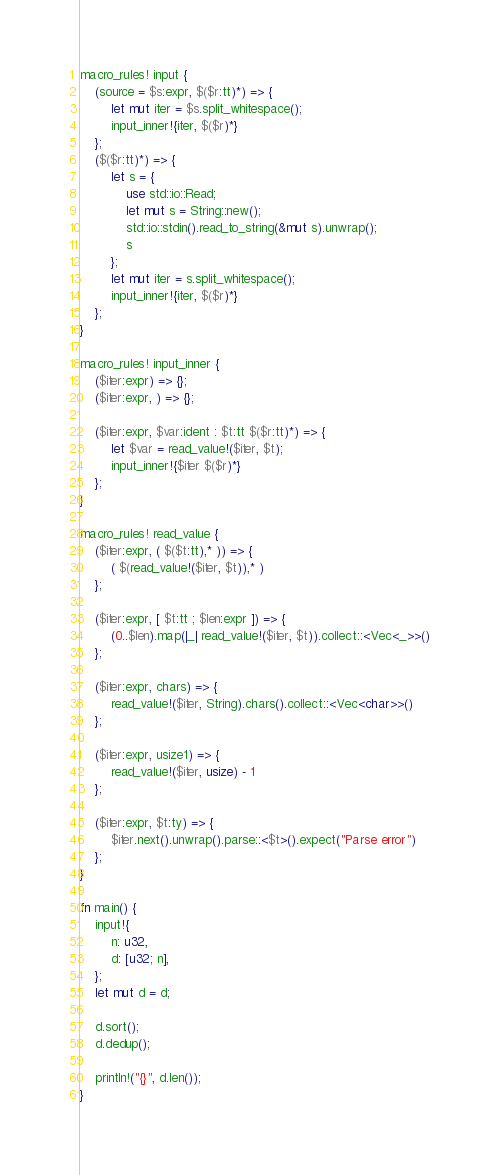<code> <loc_0><loc_0><loc_500><loc_500><_Rust_>macro_rules! input {
    (source = $s:expr, $($r:tt)*) => {
        let mut iter = $s.split_whitespace();
        input_inner!{iter, $($r)*}
    };
    ($($r:tt)*) => {
        let s = {
            use std::io::Read;
            let mut s = String::new();
            std::io::stdin().read_to_string(&mut s).unwrap();
            s
        };
        let mut iter = s.split_whitespace();
        input_inner!{iter, $($r)*}
    };
}

macro_rules! input_inner {
    ($iter:expr) => {};
    ($iter:expr, ) => {};

    ($iter:expr, $var:ident : $t:tt $($r:tt)*) => {
        let $var = read_value!($iter, $t);
        input_inner!{$iter $($r)*}
    };
}

macro_rules! read_value {
    ($iter:expr, ( $($t:tt),* )) => {
        ( $(read_value!($iter, $t)),* )
    };

    ($iter:expr, [ $t:tt ; $len:expr ]) => {
        (0..$len).map(|_| read_value!($iter, $t)).collect::<Vec<_>>()
    };

    ($iter:expr, chars) => {
        read_value!($iter, String).chars().collect::<Vec<char>>()
    };

    ($iter:expr, usize1) => {
        read_value!($iter, usize) - 1
    };

    ($iter:expr, $t:ty) => {
        $iter.next().unwrap().parse::<$t>().expect("Parse error")
    };
}

fn main() {
    input!{
        n: u32,
        d: [u32; n],
    };
    let mut d = d;

    d.sort();
    d.dedup();

    println!("{}", d.len());
}
</code> 